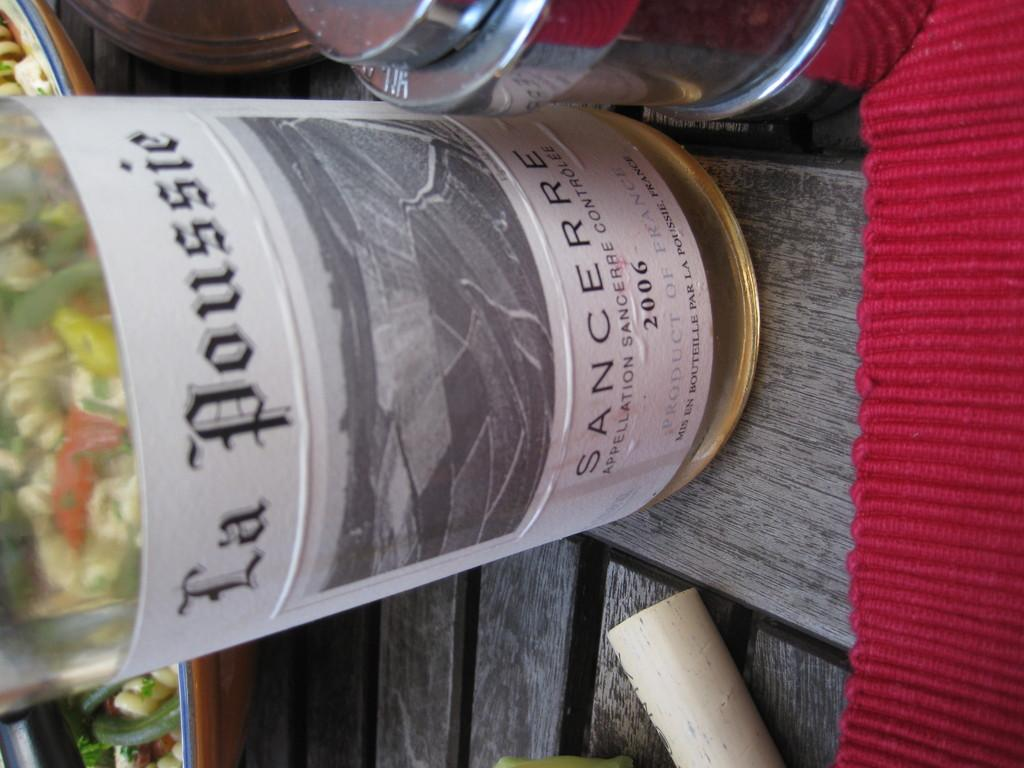<image>
Write a terse but informative summary of the picture. A bottle of La Poussie was made in 2006. 